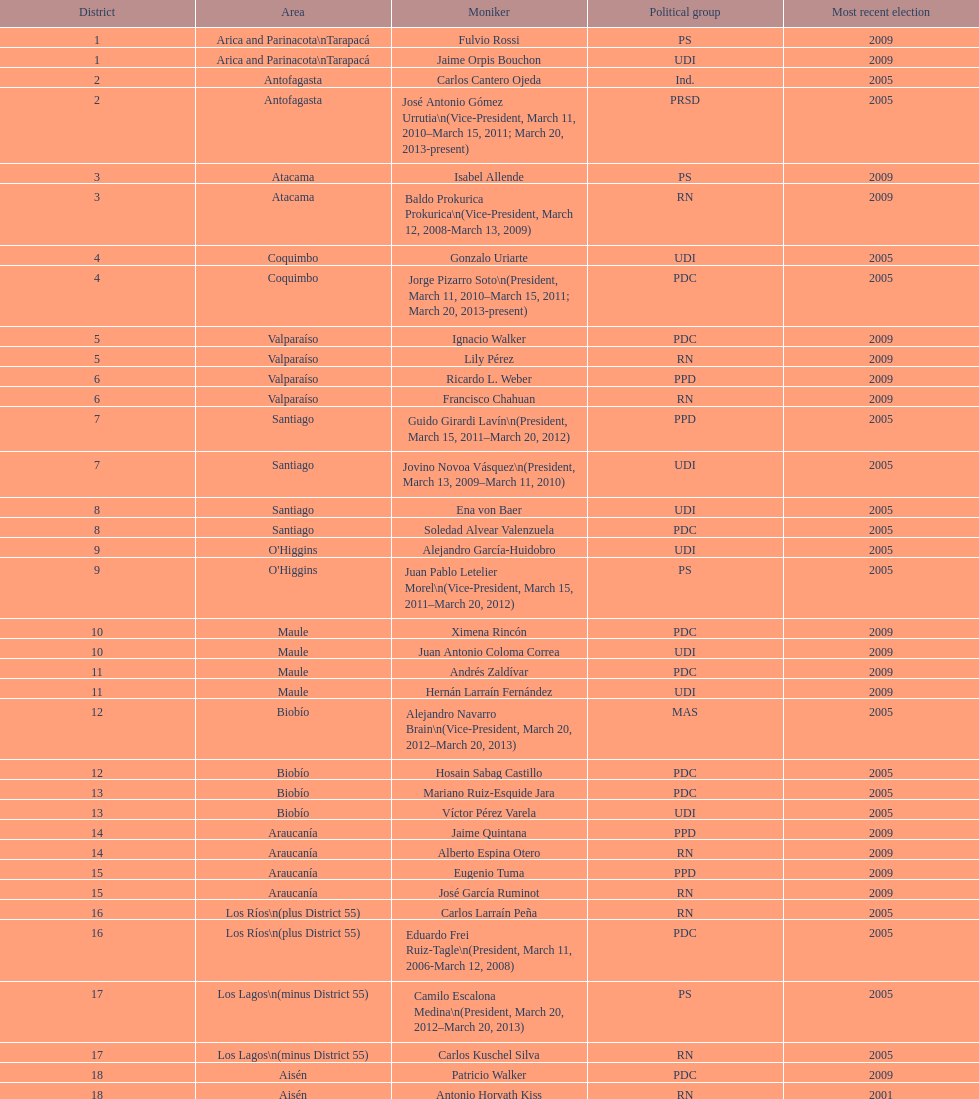Can you give me this table as a dict? {'header': ['District', 'Area', 'Moniker', 'Political group', 'Most recent election'], 'rows': [['1', 'Arica and Parinacota\\nTarapacá', 'Fulvio Rossi', 'PS', '2009'], ['1', 'Arica and Parinacota\\nTarapacá', 'Jaime Orpis Bouchon', 'UDI', '2009'], ['2', 'Antofagasta', 'Carlos Cantero Ojeda', 'Ind.', '2005'], ['2', 'Antofagasta', 'José Antonio Gómez Urrutia\\n(Vice-President, March 11, 2010–March 15, 2011; March 20, 2013-present)', 'PRSD', '2005'], ['3', 'Atacama', 'Isabel Allende', 'PS', '2009'], ['3', 'Atacama', 'Baldo Prokurica Prokurica\\n(Vice-President, March 12, 2008-March 13, 2009)', 'RN', '2009'], ['4', 'Coquimbo', 'Gonzalo Uriarte', 'UDI', '2005'], ['4', 'Coquimbo', 'Jorge Pizarro Soto\\n(President, March 11, 2010–March 15, 2011; March 20, 2013-present)', 'PDC', '2005'], ['5', 'Valparaíso', 'Ignacio Walker', 'PDC', '2009'], ['5', 'Valparaíso', 'Lily Pérez', 'RN', '2009'], ['6', 'Valparaíso', 'Ricardo L. Weber', 'PPD', '2009'], ['6', 'Valparaíso', 'Francisco Chahuan', 'RN', '2009'], ['7', 'Santiago', 'Guido Girardi Lavín\\n(President, March 15, 2011–March 20, 2012)', 'PPD', '2005'], ['7', 'Santiago', 'Jovino Novoa Vásquez\\n(President, March 13, 2009–March 11, 2010)', 'UDI', '2005'], ['8', 'Santiago', 'Ena von Baer', 'UDI', '2005'], ['8', 'Santiago', 'Soledad Alvear Valenzuela', 'PDC', '2005'], ['9', "O'Higgins", 'Alejandro García-Huidobro', 'UDI', '2005'], ['9', "O'Higgins", 'Juan Pablo Letelier Morel\\n(Vice-President, March 15, 2011–March 20, 2012)', 'PS', '2005'], ['10', 'Maule', 'Ximena Rincón', 'PDC', '2009'], ['10', 'Maule', 'Juan Antonio Coloma Correa', 'UDI', '2009'], ['11', 'Maule', 'Andrés Zaldívar', 'PDC', '2009'], ['11', 'Maule', 'Hernán Larraín Fernández', 'UDI', '2009'], ['12', 'Biobío', 'Alejandro Navarro Brain\\n(Vice-President, March 20, 2012–March 20, 2013)', 'MAS', '2005'], ['12', 'Biobío', 'Hosain Sabag Castillo', 'PDC', '2005'], ['13', 'Biobío', 'Mariano Ruiz-Esquide Jara', 'PDC', '2005'], ['13', 'Biobío', 'Víctor Pérez Varela', 'UDI', '2005'], ['14', 'Araucanía', 'Jaime Quintana', 'PPD', '2009'], ['14', 'Araucanía', 'Alberto Espina Otero', 'RN', '2009'], ['15', 'Araucanía', 'Eugenio Tuma', 'PPD', '2009'], ['15', 'Araucanía', 'José García Ruminot', 'RN', '2009'], ['16', 'Los Ríos\\n(plus District 55)', 'Carlos Larraín Peña', 'RN', '2005'], ['16', 'Los Ríos\\n(plus District 55)', 'Eduardo Frei Ruiz-Tagle\\n(President, March 11, 2006-March 12, 2008)', 'PDC', '2005'], ['17', 'Los Lagos\\n(minus District 55)', 'Camilo Escalona Medina\\n(President, March 20, 2012–March 20, 2013)', 'PS', '2005'], ['17', 'Los Lagos\\n(minus District 55)', 'Carlos Kuschel Silva', 'RN', '2005'], ['18', 'Aisén', 'Patricio Walker', 'PDC', '2009'], ['18', 'Aisén', 'Antonio Horvath Kiss', 'RN', '2001'], ['19', 'Magallanes', 'Carlos Bianchi Chelech\\n(Vice-President, March 13, 2009–March 11, 2010)', 'Ind.', '2005'], ['19', 'Magallanes', 'Pedro Muñoz Aburto', 'PS', '2005']]} Which party did jaime quintana belong to? PPD. 